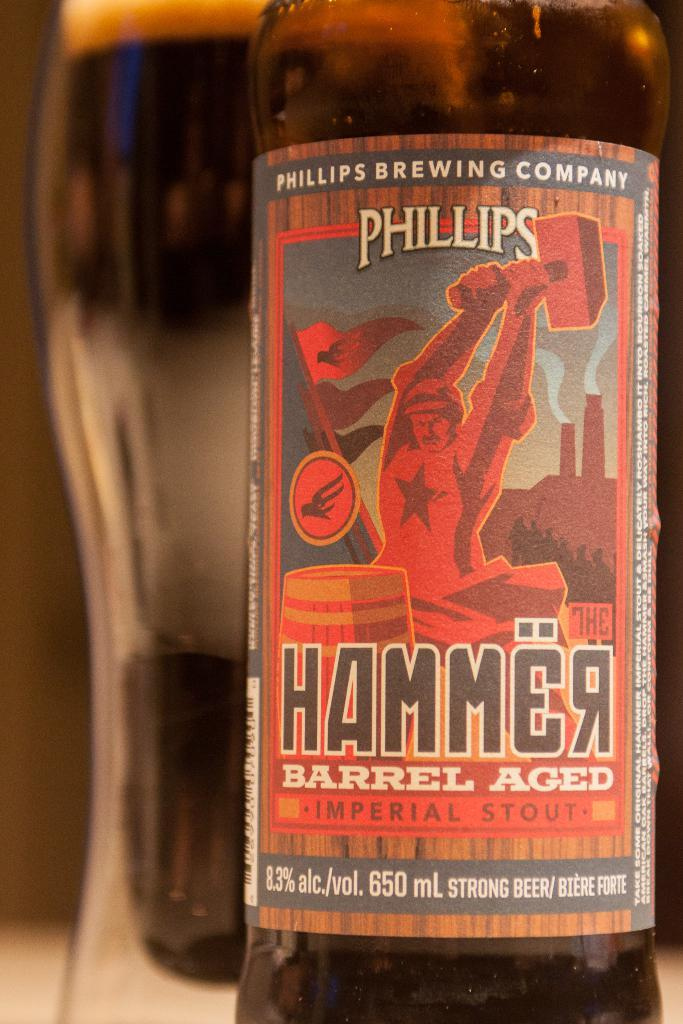<image>
Summarize the visual content of the image. a close up of Phillips Hammer Barrel Aged Stout 